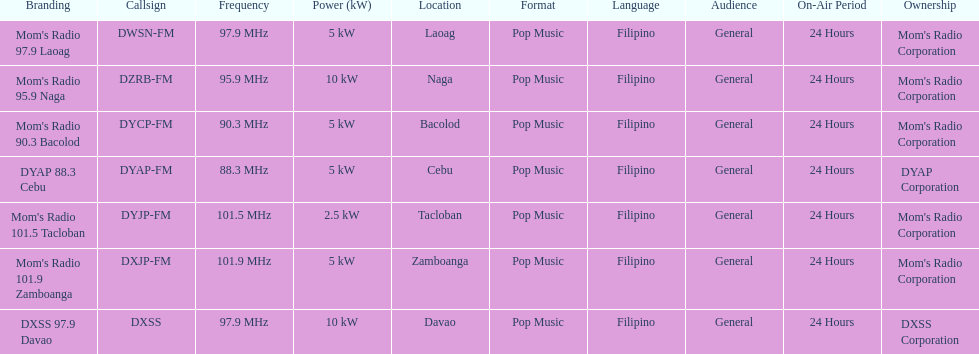How many stations broadcast with a power of 5kw? 4. 